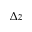Convert formula to latex. <formula><loc_0><loc_0><loc_500><loc_500>\Delta z</formula> 